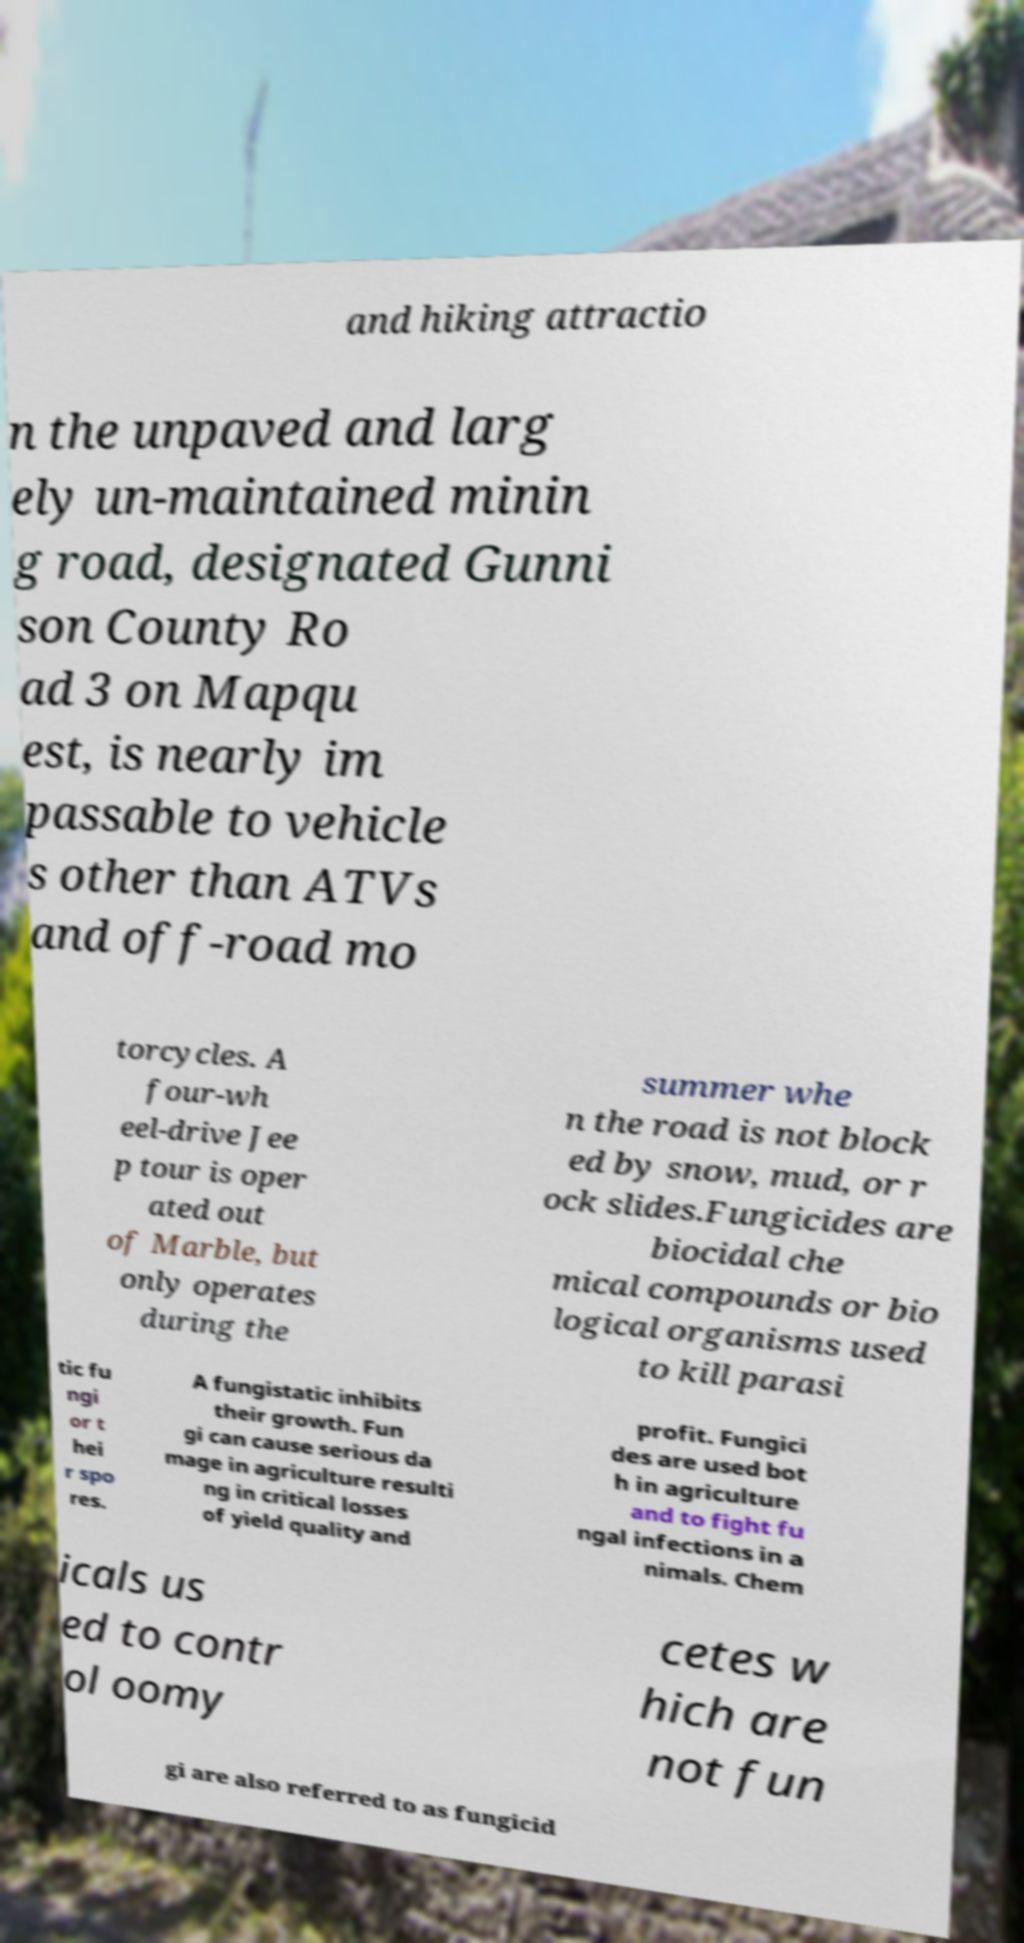There's text embedded in this image that I need extracted. Can you transcribe it verbatim? and hiking attractio n the unpaved and larg ely un-maintained minin g road, designated Gunni son County Ro ad 3 on Mapqu est, is nearly im passable to vehicle s other than ATVs and off-road mo torcycles. A four-wh eel-drive Jee p tour is oper ated out of Marble, but only operates during the summer whe n the road is not block ed by snow, mud, or r ock slides.Fungicides are biocidal che mical compounds or bio logical organisms used to kill parasi tic fu ngi or t hei r spo res. A fungistatic inhibits their growth. Fun gi can cause serious da mage in agriculture resulti ng in critical losses of yield quality and profit. Fungici des are used bot h in agriculture and to fight fu ngal infections in a nimals. Chem icals us ed to contr ol oomy cetes w hich are not fun gi are also referred to as fungicid 